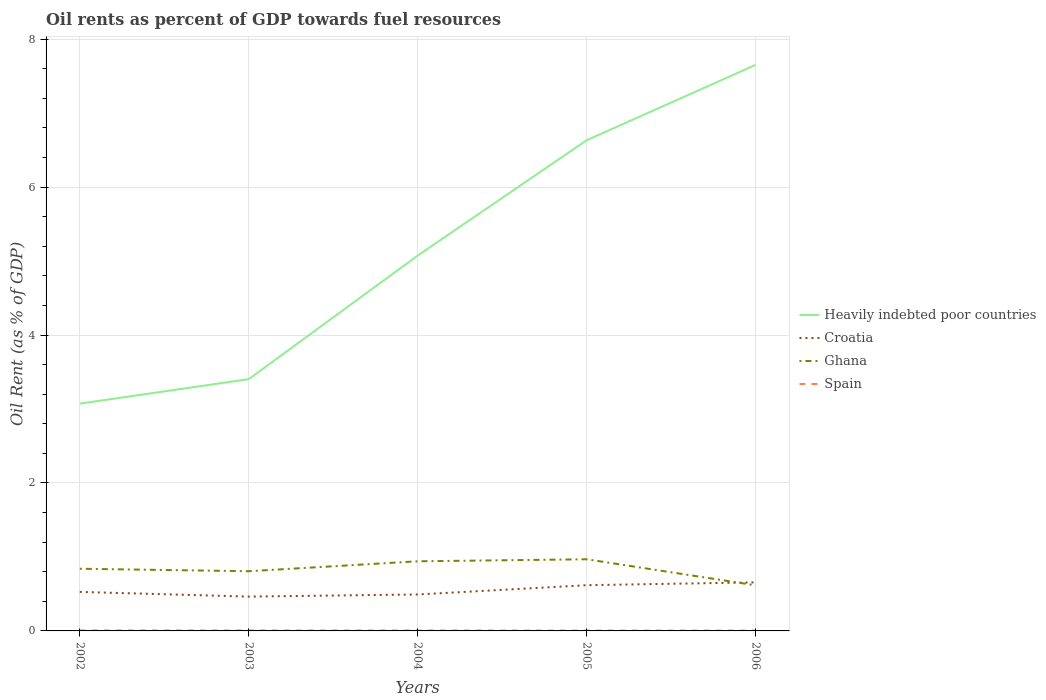How many different coloured lines are there?
Your answer should be compact. 4. Does the line corresponding to Heavily indebted poor countries intersect with the line corresponding to Croatia?
Make the answer very short. No. Across all years, what is the maximum oil rent in Spain?
Provide a succinct answer. 0. What is the total oil rent in Croatia in the graph?
Provide a succinct answer. -0.19. What is the difference between the highest and the second highest oil rent in Spain?
Offer a terse response. 0. Is the oil rent in Heavily indebted poor countries strictly greater than the oil rent in Ghana over the years?
Your response must be concise. No. How many lines are there?
Give a very brief answer. 4. How many years are there in the graph?
Provide a succinct answer. 5. What is the difference between two consecutive major ticks on the Y-axis?
Ensure brevity in your answer.  2. Are the values on the major ticks of Y-axis written in scientific E-notation?
Your answer should be compact. No. How many legend labels are there?
Give a very brief answer. 4. What is the title of the graph?
Provide a succinct answer. Oil rents as percent of GDP towards fuel resources. Does "Seychelles" appear as one of the legend labels in the graph?
Your answer should be very brief. No. What is the label or title of the Y-axis?
Your answer should be very brief. Oil Rent (as % of GDP). What is the Oil Rent (as % of GDP) in Heavily indebted poor countries in 2002?
Provide a succinct answer. 3.07. What is the Oil Rent (as % of GDP) of Croatia in 2002?
Offer a terse response. 0.53. What is the Oil Rent (as % of GDP) in Ghana in 2002?
Offer a very short reply. 0.84. What is the Oil Rent (as % of GDP) in Spain in 2002?
Your answer should be compact. 0.01. What is the Oil Rent (as % of GDP) in Heavily indebted poor countries in 2003?
Provide a succinct answer. 3.4. What is the Oil Rent (as % of GDP) of Croatia in 2003?
Provide a succinct answer. 0.46. What is the Oil Rent (as % of GDP) in Ghana in 2003?
Offer a very short reply. 0.81. What is the Oil Rent (as % of GDP) of Spain in 2003?
Give a very brief answer. 0.01. What is the Oil Rent (as % of GDP) of Heavily indebted poor countries in 2004?
Your response must be concise. 5.07. What is the Oil Rent (as % of GDP) of Croatia in 2004?
Make the answer very short. 0.49. What is the Oil Rent (as % of GDP) in Ghana in 2004?
Provide a succinct answer. 0.94. What is the Oil Rent (as % of GDP) of Spain in 2004?
Your answer should be very brief. 0.01. What is the Oil Rent (as % of GDP) in Heavily indebted poor countries in 2005?
Your answer should be very brief. 6.63. What is the Oil Rent (as % of GDP) of Croatia in 2005?
Your response must be concise. 0.62. What is the Oil Rent (as % of GDP) in Ghana in 2005?
Offer a very short reply. 0.97. What is the Oil Rent (as % of GDP) of Spain in 2005?
Give a very brief answer. 0. What is the Oil Rent (as % of GDP) in Heavily indebted poor countries in 2006?
Ensure brevity in your answer.  7.65. What is the Oil Rent (as % of GDP) of Croatia in 2006?
Provide a succinct answer. 0.66. What is the Oil Rent (as % of GDP) of Ghana in 2006?
Keep it short and to the point. 0.62. What is the Oil Rent (as % of GDP) in Spain in 2006?
Offer a very short reply. 0. Across all years, what is the maximum Oil Rent (as % of GDP) of Heavily indebted poor countries?
Keep it short and to the point. 7.65. Across all years, what is the maximum Oil Rent (as % of GDP) in Croatia?
Your response must be concise. 0.66. Across all years, what is the maximum Oil Rent (as % of GDP) in Ghana?
Your answer should be compact. 0.97. Across all years, what is the maximum Oil Rent (as % of GDP) in Spain?
Offer a very short reply. 0.01. Across all years, what is the minimum Oil Rent (as % of GDP) of Heavily indebted poor countries?
Offer a terse response. 3.07. Across all years, what is the minimum Oil Rent (as % of GDP) of Croatia?
Keep it short and to the point. 0.46. Across all years, what is the minimum Oil Rent (as % of GDP) of Ghana?
Give a very brief answer. 0.62. Across all years, what is the minimum Oil Rent (as % of GDP) in Spain?
Offer a very short reply. 0. What is the total Oil Rent (as % of GDP) of Heavily indebted poor countries in the graph?
Offer a very short reply. 25.84. What is the total Oil Rent (as % of GDP) of Croatia in the graph?
Keep it short and to the point. 2.76. What is the total Oil Rent (as % of GDP) in Ghana in the graph?
Your response must be concise. 4.17. What is the total Oil Rent (as % of GDP) of Spain in the graph?
Your response must be concise. 0.03. What is the difference between the Oil Rent (as % of GDP) of Heavily indebted poor countries in 2002 and that in 2003?
Your answer should be very brief. -0.33. What is the difference between the Oil Rent (as % of GDP) in Croatia in 2002 and that in 2003?
Your answer should be very brief. 0.06. What is the difference between the Oil Rent (as % of GDP) in Ghana in 2002 and that in 2003?
Make the answer very short. 0.03. What is the difference between the Oil Rent (as % of GDP) in Heavily indebted poor countries in 2002 and that in 2004?
Provide a succinct answer. -2. What is the difference between the Oil Rent (as % of GDP) in Croatia in 2002 and that in 2004?
Your answer should be compact. 0.03. What is the difference between the Oil Rent (as % of GDP) of Ghana in 2002 and that in 2004?
Give a very brief answer. -0.1. What is the difference between the Oil Rent (as % of GDP) in Spain in 2002 and that in 2004?
Keep it short and to the point. 0. What is the difference between the Oil Rent (as % of GDP) in Heavily indebted poor countries in 2002 and that in 2005?
Make the answer very short. -3.56. What is the difference between the Oil Rent (as % of GDP) of Croatia in 2002 and that in 2005?
Provide a short and direct response. -0.09. What is the difference between the Oil Rent (as % of GDP) in Ghana in 2002 and that in 2005?
Your answer should be compact. -0.13. What is the difference between the Oil Rent (as % of GDP) of Spain in 2002 and that in 2005?
Ensure brevity in your answer.  0. What is the difference between the Oil Rent (as % of GDP) of Heavily indebted poor countries in 2002 and that in 2006?
Ensure brevity in your answer.  -4.58. What is the difference between the Oil Rent (as % of GDP) of Croatia in 2002 and that in 2006?
Your answer should be very brief. -0.13. What is the difference between the Oil Rent (as % of GDP) of Ghana in 2002 and that in 2006?
Offer a terse response. 0.22. What is the difference between the Oil Rent (as % of GDP) in Spain in 2002 and that in 2006?
Ensure brevity in your answer.  0. What is the difference between the Oil Rent (as % of GDP) in Heavily indebted poor countries in 2003 and that in 2004?
Keep it short and to the point. -1.67. What is the difference between the Oil Rent (as % of GDP) of Croatia in 2003 and that in 2004?
Provide a succinct answer. -0.03. What is the difference between the Oil Rent (as % of GDP) of Ghana in 2003 and that in 2004?
Keep it short and to the point. -0.13. What is the difference between the Oil Rent (as % of GDP) of Spain in 2003 and that in 2004?
Give a very brief answer. 0. What is the difference between the Oil Rent (as % of GDP) in Heavily indebted poor countries in 2003 and that in 2005?
Your answer should be compact. -3.23. What is the difference between the Oil Rent (as % of GDP) in Croatia in 2003 and that in 2005?
Offer a terse response. -0.15. What is the difference between the Oil Rent (as % of GDP) in Ghana in 2003 and that in 2005?
Your response must be concise. -0.16. What is the difference between the Oil Rent (as % of GDP) of Spain in 2003 and that in 2005?
Provide a succinct answer. 0. What is the difference between the Oil Rent (as % of GDP) in Heavily indebted poor countries in 2003 and that in 2006?
Your response must be concise. -4.25. What is the difference between the Oil Rent (as % of GDP) of Croatia in 2003 and that in 2006?
Provide a succinct answer. -0.19. What is the difference between the Oil Rent (as % of GDP) of Ghana in 2003 and that in 2006?
Offer a very short reply. 0.19. What is the difference between the Oil Rent (as % of GDP) in Spain in 2003 and that in 2006?
Your answer should be compact. 0. What is the difference between the Oil Rent (as % of GDP) of Heavily indebted poor countries in 2004 and that in 2005?
Offer a very short reply. -1.56. What is the difference between the Oil Rent (as % of GDP) of Croatia in 2004 and that in 2005?
Keep it short and to the point. -0.13. What is the difference between the Oil Rent (as % of GDP) of Ghana in 2004 and that in 2005?
Offer a terse response. -0.03. What is the difference between the Oil Rent (as % of GDP) of Spain in 2004 and that in 2005?
Offer a very short reply. 0. What is the difference between the Oil Rent (as % of GDP) of Heavily indebted poor countries in 2004 and that in 2006?
Provide a short and direct response. -2.58. What is the difference between the Oil Rent (as % of GDP) in Croatia in 2004 and that in 2006?
Ensure brevity in your answer.  -0.16. What is the difference between the Oil Rent (as % of GDP) in Ghana in 2004 and that in 2006?
Provide a succinct answer. 0.32. What is the difference between the Oil Rent (as % of GDP) of Spain in 2004 and that in 2006?
Give a very brief answer. 0. What is the difference between the Oil Rent (as % of GDP) in Heavily indebted poor countries in 2005 and that in 2006?
Ensure brevity in your answer.  -1.02. What is the difference between the Oil Rent (as % of GDP) of Croatia in 2005 and that in 2006?
Make the answer very short. -0.04. What is the difference between the Oil Rent (as % of GDP) of Ghana in 2005 and that in 2006?
Provide a succinct answer. 0.35. What is the difference between the Oil Rent (as % of GDP) in Spain in 2005 and that in 2006?
Give a very brief answer. 0. What is the difference between the Oil Rent (as % of GDP) in Heavily indebted poor countries in 2002 and the Oil Rent (as % of GDP) in Croatia in 2003?
Your response must be concise. 2.61. What is the difference between the Oil Rent (as % of GDP) of Heavily indebted poor countries in 2002 and the Oil Rent (as % of GDP) of Ghana in 2003?
Ensure brevity in your answer.  2.27. What is the difference between the Oil Rent (as % of GDP) of Heavily indebted poor countries in 2002 and the Oil Rent (as % of GDP) of Spain in 2003?
Your response must be concise. 3.07. What is the difference between the Oil Rent (as % of GDP) of Croatia in 2002 and the Oil Rent (as % of GDP) of Ghana in 2003?
Keep it short and to the point. -0.28. What is the difference between the Oil Rent (as % of GDP) in Croatia in 2002 and the Oil Rent (as % of GDP) in Spain in 2003?
Offer a very short reply. 0.52. What is the difference between the Oil Rent (as % of GDP) of Ghana in 2002 and the Oil Rent (as % of GDP) of Spain in 2003?
Ensure brevity in your answer.  0.83. What is the difference between the Oil Rent (as % of GDP) in Heavily indebted poor countries in 2002 and the Oil Rent (as % of GDP) in Croatia in 2004?
Offer a terse response. 2.58. What is the difference between the Oil Rent (as % of GDP) in Heavily indebted poor countries in 2002 and the Oil Rent (as % of GDP) in Ghana in 2004?
Your response must be concise. 2.13. What is the difference between the Oil Rent (as % of GDP) in Heavily indebted poor countries in 2002 and the Oil Rent (as % of GDP) in Spain in 2004?
Provide a short and direct response. 3.07. What is the difference between the Oil Rent (as % of GDP) of Croatia in 2002 and the Oil Rent (as % of GDP) of Ghana in 2004?
Provide a short and direct response. -0.41. What is the difference between the Oil Rent (as % of GDP) of Croatia in 2002 and the Oil Rent (as % of GDP) of Spain in 2004?
Give a very brief answer. 0.52. What is the difference between the Oil Rent (as % of GDP) of Ghana in 2002 and the Oil Rent (as % of GDP) of Spain in 2004?
Your response must be concise. 0.84. What is the difference between the Oil Rent (as % of GDP) in Heavily indebted poor countries in 2002 and the Oil Rent (as % of GDP) in Croatia in 2005?
Make the answer very short. 2.45. What is the difference between the Oil Rent (as % of GDP) of Heavily indebted poor countries in 2002 and the Oil Rent (as % of GDP) of Ghana in 2005?
Make the answer very short. 2.1. What is the difference between the Oil Rent (as % of GDP) of Heavily indebted poor countries in 2002 and the Oil Rent (as % of GDP) of Spain in 2005?
Offer a very short reply. 3.07. What is the difference between the Oil Rent (as % of GDP) of Croatia in 2002 and the Oil Rent (as % of GDP) of Ghana in 2005?
Make the answer very short. -0.44. What is the difference between the Oil Rent (as % of GDP) in Croatia in 2002 and the Oil Rent (as % of GDP) in Spain in 2005?
Provide a short and direct response. 0.52. What is the difference between the Oil Rent (as % of GDP) of Ghana in 2002 and the Oil Rent (as % of GDP) of Spain in 2005?
Your answer should be compact. 0.84. What is the difference between the Oil Rent (as % of GDP) in Heavily indebted poor countries in 2002 and the Oil Rent (as % of GDP) in Croatia in 2006?
Keep it short and to the point. 2.42. What is the difference between the Oil Rent (as % of GDP) of Heavily indebted poor countries in 2002 and the Oil Rent (as % of GDP) of Ghana in 2006?
Make the answer very short. 2.46. What is the difference between the Oil Rent (as % of GDP) of Heavily indebted poor countries in 2002 and the Oil Rent (as % of GDP) of Spain in 2006?
Offer a terse response. 3.07. What is the difference between the Oil Rent (as % of GDP) of Croatia in 2002 and the Oil Rent (as % of GDP) of Ghana in 2006?
Your response must be concise. -0.09. What is the difference between the Oil Rent (as % of GDP) in Croatia in 2002 and the Oil Rent (as % of GDP) in Spain in 2006?
Your answer should be compact. 0.52. What is the difference between the Oil Rent (as % of GDP) of Ghana in 2002 and the Oil Rent (as % of GDP) of Spain in 2006?
Provide a short and direct response. 0.84. What is the difference between the Oil Rent (as % of GDP) in Heavily indebted poor countries in 2003 and the Oil Rent (as % of GDP) in Croatia in 2004?
Offer a very short reply. 2.91. What is the difference between the Oil Rent (as % of GDP) in Heavily indebted poor countries in 2003 and the Oil Rent (as % of GDP) in Ghana in 2004?
Make the answer very short. 2.46. What is the difference between the Oil Rent (as % of GDP) in Heavily indebted poor countries in 2003 and the Oil Rent (as % of GDP) in Spain in 2004?
Provide a short and direct response. 3.4. What is the difference between the Oil Rent (as % of GDP) in Croatia in 2003 and the Oil Rent (as % of GDP) in Ghana in 2004?
Offer a terse response. -0.48. What is the difference between the Oil Rent (as % of GDP) of Croatia in 2003 and the Oil Rent (as % of GDP) of Spain in 2004?
Keep it short and to the point. 0.46. What is the difference between the Oil Rent (as % of GDP) of Ghana in 2003 and the Oil Rent (as % of GDP) of Spain in 2004?
Ensure brevity in your answer.  0.8. What is the difference between the Oil Rent (as % of GDP) in Heavily indebted poor countries in 2003 and the Oil Rent (as % of GDP) in Croatia in 2005?
Ensure brevity in your answer.  2.79. What is the difference between the Oil Rent (as % of GDP) of Heavily indebted poor countries in 2003 and the Oil Rent (as % of GDP) of Ghana in 2005?
Provide a short and direct response. 2.44. What is the difference between the Oil Rent (as % of GDP) in Heavily indebted poor countries in 2003 and the Oil Rent (as % of GDP) in Spain in 2005?
Keep it short and to the point. 3.4. What is the difference between the Oil Rent (as % of GDP) of Croatia in 2003 and the Oil Rent (as % of GDP) of Ghana in 2005?
Ensure brevity in your answer.  -0.5. What is the difference between the Oil Rent (as % of GDP) of Croatia in 2003 and the Oil Rent (as % of GDP) of Spain in 2005?
Provide a succinct answer. 0.46. What is the difference between the Oil Rent (as % of GDP) in Ghana in 2003 and the Oil Rent (as % of GDP) in Spain in 2005?
Your response must be concise. 0.8. What is the difference between the Oil Rent (as % of GDP) in Heavily indebted poor countries in 2003 and the Oil Rent (as % of GDP) in Croatia in 2006?
Ensure brevity in your answer.  2.75. What is the difference between the Oil Rent (as % of GDP) of Heavily indebted poor countries in 2003 and the Oil Rent (as % of GDP) of Ghana in 2006?
Provide a succinct answer. 2.79. What is the difference between the Oil Rent (as % of GDP) in Heavily indebted poor countries in 2003 and the Oil Rent (as % of GDP) in Spain in 2006?
Your answer should be compact. 3.4. What is the difference between the Oil Rent (as % of GDP) of Croatia in 2003 and the Oil Rent (as % of GDP) of Ghana in 2006?
Offer a terse response. -0.15. What is the difference between the Oil Rent (as % of GDP) in Croatia in 2003 and the Oil Rent (as % of GDP) in Spain in 2006?
Keep it short and to the point. 0.46. What is the difference between the Oil Rent (as % of GDP) of Ghana in 2003 and the Oil Rent (as % of GDP) of Spain in 2006?
Provide a succinct answer. 0.8. What is the difference between the Oil Rent (as % of GDP) in Heavily indebted poor countries in 2004 and the Oil Rent (as % of GDP) in Croatia in 2005?
Offer a terse response. 4.46. What is the difference between the Oil Rent (as % of GDP) in Heavily indebted poor countries in 2004 and the Oil Rent (as % of GDP) in Ghana in 2005?
Give a very brief answer. 4.11. What is the difference between the Oil Rent (as % of GDP) in Heavily indebted poor countries in 2004 and the Oil Rent (as % of GDP) in Spain in 2005?
Offer a very short reply. 5.07. What is the difference between the Oil Rent (as % of GDP) of Croatia in 2004 and the Oil Rent (as % of GDP) of Ghana in 2005?
Ensure brevity in your answer.  -0.48. What is the difference between the Oil Rent (as % of GDP) in Croatia in 2004 and the Oil Rent (as % of GDP) in Spain in 2005?
Provide a short and direct response. 0.49. What is the difference between the Oil Rent (as % of GDP) of Ghana in 2004 and the Oil Rent (as % of GDP) of Spain in 2005?
Ensure brevity in your answer.  0.94. What is the difference between the Oil Rent (as % of GDP) in Heavily indebted poor countries in 2004 and the Oil Rent (as % of GDP) in Croatia in 2006?
Your response must be concise. 4.42. What is the difference between the Oil Rent (as % of GDP) in Heavily indebted poor countries in 2004 and the Oil Rent (as % of GDP) in Ghana in 2006?
Offer a terse response. 4.46. What is the difference between the Oil Rent (as % of GDP) in Heavily indebted poor countries in 2004 and the Oil Rent (as % of GDP) in Spain in 2006?
Give a very brief answer. 5.07. What is the difference between the Oil Rent (as % of GDP) of Croatia in 2004 and the Oil Rent (as % of GDP) of Ghana in 2006?
Your answer should be compact. -0.12. What is the difference between the Oil Rent (as % of GDP) in Croatia in 2004 and the Oil Rent (as % of GDP) in Spain in 2006?
Make the answer very short. 0.49. What is the difference between the Oil Rent (as % of GDP) of Ghana in 2004 and the Oil Rent (as % of GDP) of Spain in 2006?
Ensure brevity in your answer.  0.94. What is the difference between the Oil Rent (as % of GDP) in Heavily indebted poor countries in 2005 and the Oil Rent (as % of GDP) in Croatia in 2006?
Provide a short and direct response. 5.98. What is the difference between the Oil Rent (as % of GDP) in Heavily indebted poor countries in 2005 and the Oil Rent (as % of GDP) in Ghana in 2006?
Offer a very short reply. 6.02. What is the difference between the Oil Rent (as % of GDP) of Heavily indebted poor countries in 2005 and the Oil Rent (as % of GDP) of Spain in 2006?
Provide a short and direct response. 6.63. What is the difference between the Oil Rent (as % of GDP) of Croatia in 2005 and the Oil Rent (as % of GDP) of Ghana in 2006?
Keep it short and to the point. 0. What is the difference between the Oil Rent (as % of GDP) of Croatia in 2005 and the Oil Rent (as % of GDP) of Spain in 2006?
Offer a terse response. 0.61. What is the difference between the Oil Rent (as % of GDP) of Ghana in 2005 and the Oil Rent (as % of GDP) of Spain in 2006?
Offer a terse response. 0.96. What is the average Oil Rent (as % of GDP) of Heavily indebted poor countries per year?
Your answer should be compact. 5.17. What is the average Oil Rent (as % of GDP) in Croatia per year?
Provide a succinct answer. 0.55. What is the average Oil Rent (as % of GDP) in Ghana per year?
Your response must be concise. 0.83. What is the average Oil Rent (as % of GDP) in Spain per year?
Your answer should be very brief. 0.01. In the year 2002, what is the difference between the Oil Rent (as % of GDP) in Heavily indebted poor countries and Oil Rent (as % of GDP) in Croatia?
Ensure brevity in your answer.  2.55. In the year 2002, what is the difference between the Oil Rent (as % of GDP) in Heavily indebted poor countries and Oil Rent (as % of GDP) in Ghana?
Your answer should be very brief. 2.23. In the year 2002, what is the difference between the Oil Rent (as % of GDP) of Heavily indebted poor countries and Oil Rent (as % of GDP) of Spain?
Give a very brief answer. 3.07. In the year 2002, what is the difference between the Oil Rent (as % of GDP) of Croatia and Oil Rent (as % of GDP) of Ghana?
Ensure brevity in your answer.  -0.31. In the year 2002, what is the difference between the Oil Rent (as % of GDP) of Croatia and Oil Rent (as % of GDP) of Spain?
Offer a very short reply. 0.52. In the year 2002, what is the difference between the Oil Rent (as % of GDP) in Ghana and Oil Rent (as % of GDP) in Spain?
Your response must be concise. 0.83. In the year 2003, what is the difference between the Oil Rent (as % of GDP) of Heavily indebted poor countries and Oil Rent (as % of GDP) of Croatia?
Ensure brevity in your answer.  2.94. In the year 2003, what is the difference between the Oil Rent (as % of GDP) of Heavily indebted poor countries and Oil Rent (as % of GDP) of Ghana?
Your answer should be very brief. 2.6. In the year 2003, what is the difference between the Oil Rent (as % of GDP) in Heavily indebted poor countries and Oil Rent (as % of GDP) in Spain?
Your answer should be very brief. 3.4. In the year 2003, what is the difference between the Oil Rent (as % of GDP) of Croatia and Oil Rent (as % of GDP) of Ghana?
Your answer should be compact. -0.34. In the year 2003, what is the difference between the Oil Rent (as % of GDP) in Croatia and Oil Rent (as % of GDP) in Spain?
Make the answer very short. 0.46. In the year 2003, what is the difference between the Oil Rent (as % of GDP) in Ghana and Oil Rent (as % of GDP) in Spain?
Offer a terse response. 0.8. In the year 2004, what is the difference between the Oil Rent (as % of GDP) in Heavily indebted poor countries and Oil Rent (as % of GDP) in Croatia?
Offer a very short reply. 4.58. In the year 2004, what is the difference between the Oil Rent (as % of GDP) of Heavily indebted poor countries and Oil Rent (as % of GDP) of Ghana?
Offer a terse response. 4.13. In the year 2004, what is the difference between the Oil Rent (as % of GDP) in Heavily indebted poor countries and Oil Rent (as % of GDP) in Spain?
Offer a terse response. 5.07. In the year 2004, what is the difference between the Oil Rent (as % of GDP) of Croatia and Oil Rent (as % of GDP) of Ghana?
Your answer should be very brief. -0.45. In the year 2004, what is the difference between the Oil Rent (as % of GDP) of Croatia and Oil Rent (as % of GDP) of Spain?
Ensure brevity in your answer.  0.49. In the year 2004, what is the difference between the Oil Rent (as % of GDP) in Ghana and Oil Rent (as % of GDP) in Spain?
Ensure brevity in your answer.  0.94. In the year 2005, what is the difference between the Oil Rent (as % of GDP) in Heavily indebted poor countries and Oil Rent (as % of GDP) in Croatia?
Keep it short and to the point. 6.02. In the year 2005, what is the difference between the Oil Rent (as % of GDP) in Heavily indebted poor countries and Oil Rent (as % of GDP) in Ghana?
Give a very brief answer. 5.67. In the year 2005, what is the difference between the Oil Rent (as % of GDP) in Heavily indebted poor countries and Oil Rent (as % of GDP) in Spain?
Make the answer very short. 6.63. In the year 2005, what is the difference between the Oil Rent (as % of GDP) in Croatia and Oil Rent (as % of GDP) in Ghana?
Keep it short and to the point. -0.35. In the year 2005, what is the difference between the Oil Rent (as % of GDP) in Croatia and Oil Rent (as % of GDP) in Spain?
Ensure brevity in your answer.  0.61. In the year 2005, what is the difference between the Oil Rent (as % of GDP) in Ghana and Oil Rent (as % of GDP) in Spain?
Provide a succinct answer. 0.96. In the year 2006, what is the difference between the Oil Rent (as % of GDP) of Heavily indebted poor countries and Oil Rent (as % of GDP) of Croatia?
Your answer should be compact. 7. In the year 2006, what is the difference between the Oil Rent (as % of GDP) of Heavily indebted poor countries and Oil Rent (as % of GDP) of Ghana?
Make the answer very short. 7.04. In the year 2006, what is the difference between the Oil Rent (as % of GDP) of Heavily indebted poor countries and Oil Rent (as % of GDP) of Spain?
Your answer should be compact. 7.65. In the year 2006, what is the difference between the Oil Rent (as % of GDP) in Croatia and Oil Rent (as % of GDP) in Spain?
Provide a succinct answer. 0.65. In the year 2006, what is the difference between the Oil Rent (as % of GDP) in Ghana and Oil Rent (as % of GDP) in Spain?
Offer a terse response. 0.61. What is the ratio of the Oil Rent (as % of GDP) of Heavily indebted poor countries in 2002 to that in 2003?
Ensure brevity in your answer.  0.9. What is the ratio of the Oil Rent (as % of GDP) in Croatia in 2002 to that in 2003?
Your answer should be very brief. 1.14. What is the ratio of the Oil Rent (as % of GDP) in Ghana in 2002 to that in 2003?
Ensure brevity in your answer.  1.04. What is the ratio of the Oil Rent (as % of GDP) of Spain in 2002 to that in 2003?
Provide a succinct answer. 1.05. What is the ratio of the Oil Rent (as % of GDP) of Heavily indebted poor countries in 2002 to that in 2004?
Offer a very short reply. 0.61. What is the ratio of the Oil Rent (as % of GDP) in Croatia in 2002 to that in 2004?
Provide a succinct answer. 1.07. What is the ratio of the Oil Rent (as % of GDP) of Ghana in 2002 to that in 2004?
Provide a succinct answer. 0.89. What is the ratio of the Oil Rent (as % of GDP) in Spain in 2002 to that in 2004?
Provide a succinct answer. 1.14. What is the ratio of the Oil Rent (as % of GDP) of Heavily indebted poor countries in 2002 to that in 2005?
Give a very brief answer. 0.46. What is the ratio of the Oil Rent (as % of GDP) in Croatia in 2002 to that in 2005?
Make the answer very short. 0.85. What is the ratio of the Oil Rent (as % of GDP) in Ghana in 2002 to that in 2005?
Make the answer very short. 0.87. What is the ratio of the Oil Rent (as % of GDP) in Spain in 2002 to that in 2005?
Offer a very short reply. 1.29. What is the ratio of the Oil Rent (as % of GDP) of Heavily indebted poor countries in 2002 to that in 2006?
Give a very brief answer. 0.4. What is the ratio of the Oil Rent (as % of GDP) of Croatia in 2002 to that in 2006?
Give a very brief answer. 0.8. What is the ratio of the Oil Rent (as % of GDP) in Ghana in 2002 to that in 2006?
Make the answer very short. 1.36. What is the ratio of the Oil Rent (as % of GDP) in Spain in 2002 to that in 2006?
Provide a succinct answer. 1.39. What is the ratio of the Oil Rent (as % of GDP) of Heavily indebted poor countries in 2003 to that in 2004?
Provide a short and direct response. 0.67. What is the ratio of the Oil Rent (as % of GDP) in Croatia in 2003 to that in 2004?
Ensure brevity in your answer.  0.94. What is the ratio of the Oil Rent (as % of GDP) of Ghana in 2003 to that in 2004?
Make the answer very short. 0.86. What is the ratio of the Oil Rent (as % of GDP) of Spain in 2003 to that in 2004?
Make the answer very short. 1.08. What is the ratio of the Oil Rent (as % of GDP) in Heavily indebted poor countries in 2003 to that in 2005?
Ensure brevity in your answer.  0.51. What is the ratio of the Oil Rent (as % of GDP) in Croatia in 2003 to that in 2005?
Offer a very short reply. 0.75. What is the ratio of the Oil Rent (as % of GDP) of Ghana in 2003 to that in 2005?
Your answer should be very brief. 0.83. What is the ratio of the Oil Rent (as % of GDP) in Spain in 2003 to that in 2005?
Provide a succinct answer. 1.23. What is the ratio of the Oil Rent (as % of GDP) of Heavily indebted poor countries in 2003 to that in 2006?
Give a very brief answer. 0.44. What is the ratio of the Oil Rent (as % of GDP) in Croatia in 2003 to that in 2006?
Make the answer very short. 0.71. What is the ratio of the Oil Rent (as % of GDP) in Ghana in 2003 to that in 2006?
Offer a terse response. 1.31. What is the ratio of the Oil Rent (as % of GDP) of Spain in 2003 to that in 2006?
Offer a very short reply. 1.32. What is the ratio of the Oil Rent (as % of GDP) in Heavily indebted poor countries in 2004 to that in 2005?
Keep it short and to the point. 0.77. What is the ratio of the Oil Rent (as % of GDP) of Croatia in 2004 to that in 2005?
Make the answer very short. 0.8. What is the ratio of the Oil Rent (as % of GDP) of Ghana in 2004 to that in 2005?
Ensure brevity in your answer.  0.97. What is the ratio of the Oil Rent (as % of GDP) of Spain in 2004 to that in 2005?
Your answer should be very brief. 1.13. What is the ratio of the Oil Rent (as % of GDP) of Heavily indebted poor countries in 2004 to that in 2006?
Your response must be concise. 0.66. What is the ratio of the Oil Rent (as % of GDP) of Croatia in 2004 to that in 2006?
Offer a very short reply. 0.75. What is the ratio of the Oil Rent (as % of GDP) of Ghana in 2004 to that in 2006?
Keep it short and to the point. 1.53. What is the ratio of the Oil Rent (as % of GDP) in Spain in 2004 to that in 2006?
Offer a terse response. 1.22. What is the ratio of the Oil Rent (as % of GDP) in Heavily indebted poor countries in 2005 to that in 2006?
Provide a short and direct response. 0.87. What is the ratio of the Oil Rent (as % of GDP) of Croatia in 2005 to that in 2006?
Your response must be concise. 0.94. What is the ratio of the Oil Rent (as % of GDP) in Ghana in 2005 to that in 2006?
Provide a short and direct response. 1.57. What is the ratio of the Oil Rent (as % of GDP) of Spain in 2005 to that in 2006?
Offer a terse response. 1.08. What is the difference between the highest and the second highest Oil Rent (as % of GDP) of Heavily indebted poor countries?
Give a very brief answer. 1.02. What is the difference between the highest and the second highest Oil Rent (as % of GDP) of Croatia?
Give a very brief answer. 0.04. What is the difference between the highest and the second highest Oil Rent (as % of GDP) of Ghana?
Offer a very short reply. 0.03. What is the difference between the highest and the lowest Oil Rent (as % of GDP) of Heavily indebted poor countries?
Keep it short and to the point. 4.58. What is the difference between the highest and the lowest Oil Rent (as % of GDP) in Croatia?
Provide a succinct answer. 0.19. What is the difference between the highest and the lowest Oil Rent (as % of GDP) in Ghana?
Keep it short and to the point. 0.35. What is the difference between the highest and the lowest Oil Rent (as % of GDP) of Spain?
Give a very brief answer. 0. 